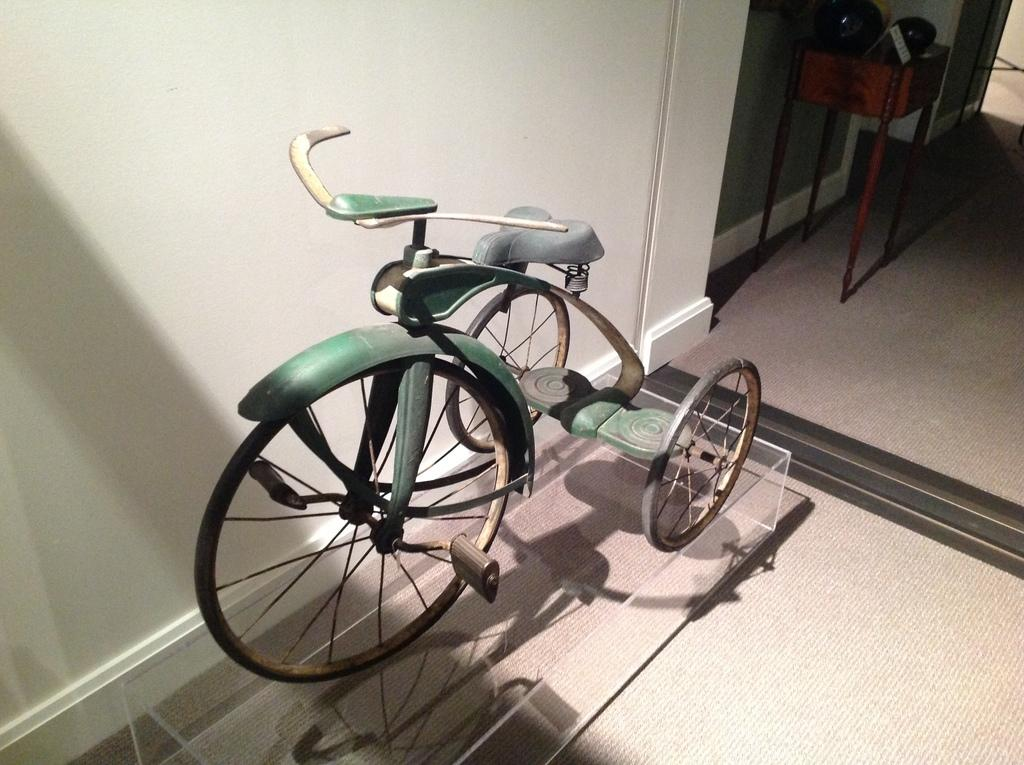What is the main object in the image? There is a cycle in the image. What is the cycle placed on? The cycle is placed on a glass object. What type of structure can be seen in the image? There is a wall in the image. What piece of furniture is present in the image? There is a table in the image. How many geese are sitting on the table in the image? There are no geese present in the image; the table only contains the cycle and the glass object. What type of pan is visible on the wall in the image? There is no pan visible on the wall in the image; only the cycle, glass object, wall, and table are present. 